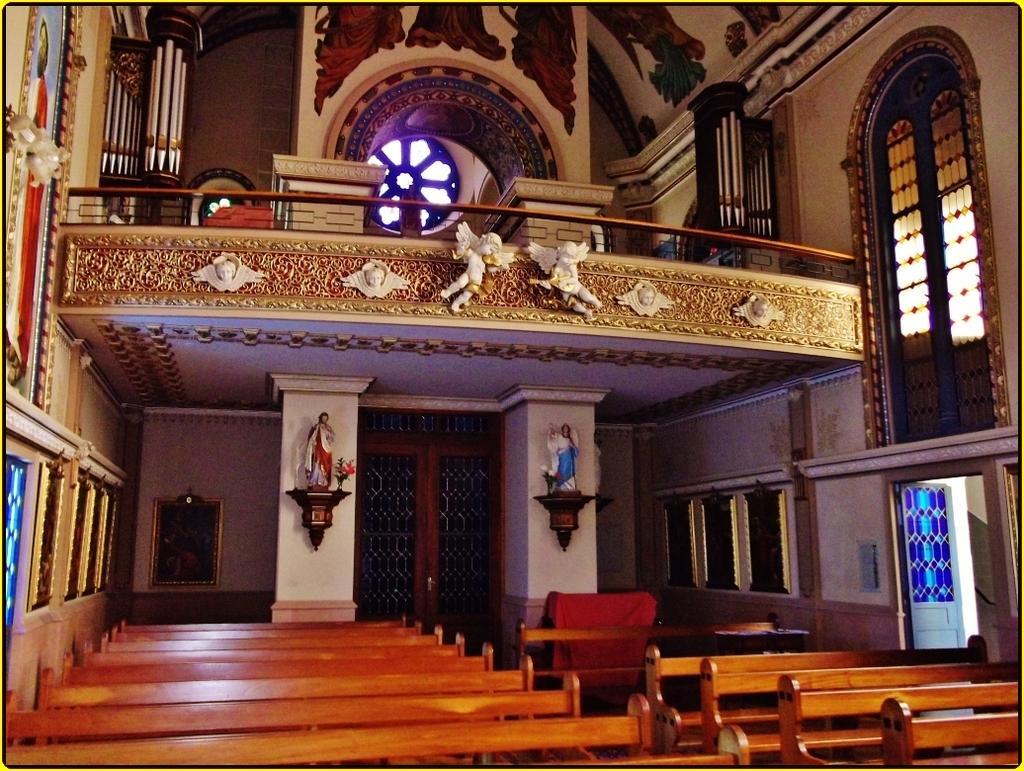Can you describe this image briefly? In this image we can see few benches in a room, doors, windows and statues attached to the wall. 